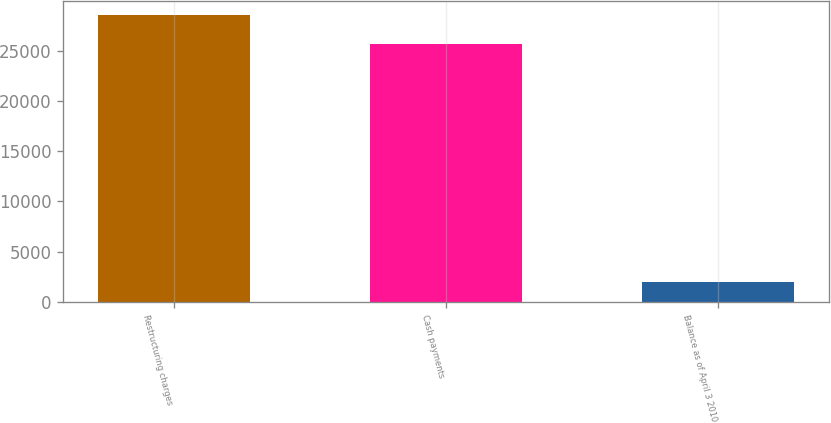Convert chart. <chart><loc_0><loc_0><loc_500><loc_500><bar_chart><fcel>Restructuring charges<fcel>Cash payments<fcel>Balance as of April 3 2010<nl><fcel>28531<fcel>25633<fcel>1953<nl></chart> 